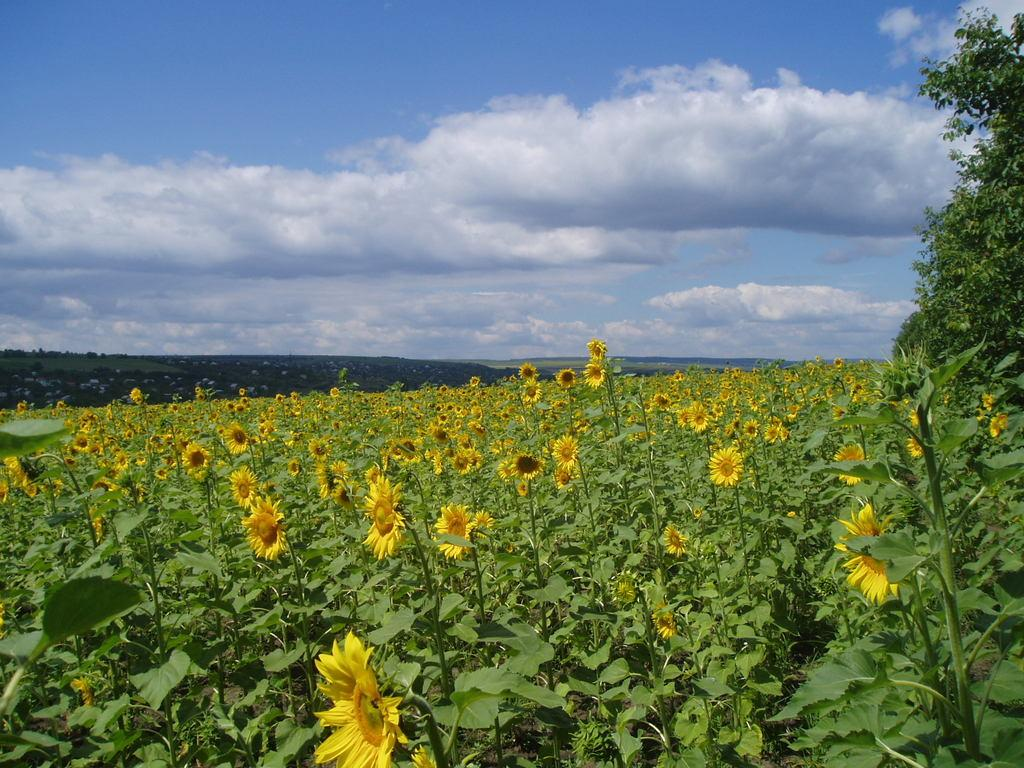What type of vegetation can be seen in the image? There are plants, flowers, and trees in the image. Can you describe the sky in the background of the image? The sky is visible in the background of the image, and there are clouds present. What is the primary difference between the plants and trees in the image? The plants are smaller and may be flowering, while the trees are larger and have a more extensive structure. What type of pest can be seen crawling on the tomatoes in the image? There are no tomatoes present in the image, and therefore no pests can be observed. 